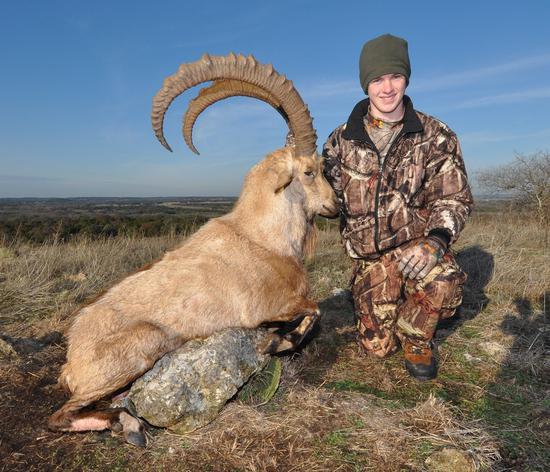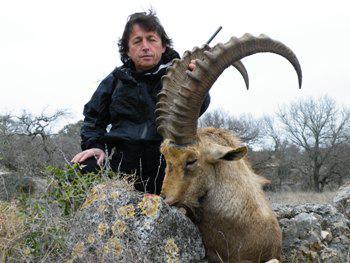The first image is the image on the left, the second image is the image on the right. Analyze the images presented: Is the assertion "An image shows a person in a hat and camo-patterned top posed next to a long-horned animal." valid? Answer yes or no. Yes. 